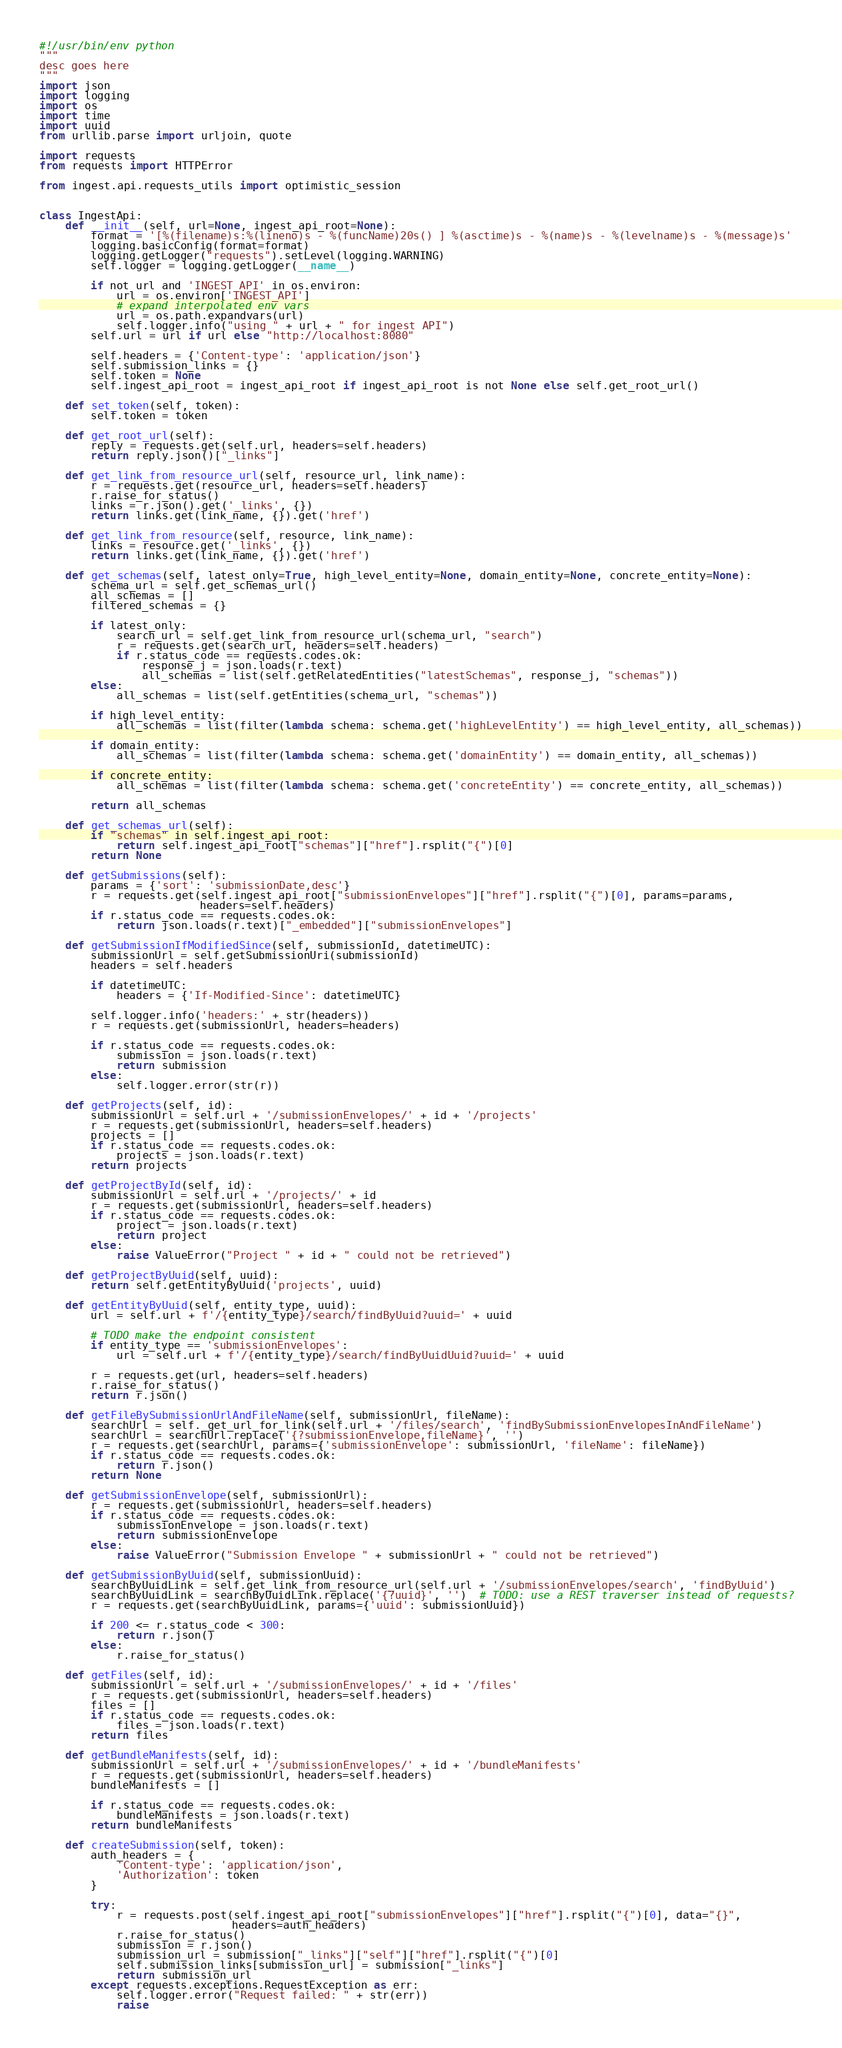Convert code to text. <code><loc_0><loc_0><loc_500><loc_500><_Python_>#!/usr/bin/env python
"""
desc goes here
"""
import json
import logging
import os
import time
import uuid
from urllib.parse import urljoin, quote

import requests
from requests import HTTPError

from ingest.api.requests_utils import optimistic_session


class IngestApi:
    def __init__(self, url=None, ingest_api_root=None):
        format = '[%(filename)s:%(lineno)s - %(funcName)20s() ] %(asctime)s - %(name)s - %(levelname)s - %(message)s'
        logging.basicConfig(format=format)
        logging.getLogger("requests").setLevel(logging.WARNING)
        self.logger = logging.getLogger(__name__)

        if not url and 'INGEST_API' in os.environ:
            url = os.environ['INGEST_API']
            # expand interpolated env vars
            url = os.path.expandvars(url)
            self.logger.info("using " + url + " for ingest API")
        self.url = url if url else "http://localhost:8080"

        self.headers = {'Content-type': 'application/json'}
        self.submission_links = {}
        self.token = None
        self.ingest_api_root = ingest_api_root if ingest_api_root is not None else self.get_root_url()

    def set_token(self, token):
        self.token = token

    def get_root_url(self):
        reply = requests.get(self.url, headers=self.headers)
        return reply.json()["_links"]

    def get_link_from_resource_url(self, resource_url, link_name):
        r = requests.get(resource_url, headers=self.headers)
        r.raise_for_status()
        links = r.json().get('_links', {})
        return links.get(link_name, {}).get('href')

    def get_link_from_resource(self, resource, link_name):
        links = resource.get('_links', {})
        return links.get(link_name, {}).get('href')

    def get_schemas(self, latest_only=True, high_level_entity=None, domain_entity=None, concrete_entity=None):
        schema_url = self.get_schemas_url()
        all_schemas = []
        filtered_schemas = {}

        if latest_only:
            search_url = self.get_link_from_resource_url(schema_url, "search")
            r = requests.get(search_url, headers=self.headers)
            if r.status_code == requests.codes.ok:
                response_j = json.loads(r.text)
                all_schemas = list(self.getRelatedEntities("latestSchemas", response_j, "schemas"))
        else:
            all_schemas = list(self.getEntities(schema_url, "schemas"))

        if high_level_entity:
            all_schemas = list(filter(lambda schema: schema.get('highLevelEntity') == high_level_entity, all_schemas))

        if domain_entity:
            all_schemas = list(filter(lambda schema: schema.get('domainEntity') == domain_entity, all_schemas))

        if concrete_entity:
            all_schemas = list(filter(lambda schema: schema.get('concreteEntity') == concrete_entity, all_schemas))

        return all_schemas

    def get_schemas_url(self):
        if "schemas" in self.ingest_api_root:
            return self.ingest_api_root["schemas"]["href"].rsplit("{")[0]
        return None

    def getSubmissions(self):
        params = {'sort': 'submissionDate,desc'}
        r = requests.get(self.ingest_api_root["submissionEnvelopes"]["href"].rsplit("{")[0], params=params,
                         headers=self.headers)
        if r.status_code == requests.codes.ok:
            return json.loads(r.text)["_embedded"]["submissionEnvelopes"]

    def getSubmissionIfModifiedSince(self, submissionId, datetimeUTC):
        submissionUrl = self.getSubmissionUri(submissionId)
        headers = self.headers

        if datetimeUTC:
            headers = {'If-Modified-Since': datetimeUTC}

        self.logger.info('headers:' + str(headers))
        r = requests.get(submissionUrl, headers=headers)

        if r.status_code == requests.codes.ok:
            submission = json.loads(r.text)
            return submission
        else:
            self.logger.error(str(r))

    def getProjects(self, id):
        submissionUrl = self.url + '/submissionEnvelopes/' + id + '/projects'
        r = requests.get(submissionUrl, headers=self.headers)
        projects = []
        if r.status_code == requests.codes.ok:
            projects = json.loads(r.text)
        return projects

    def getProjectById(self, id):
        submissionUrl = self.url + '/projects/' + id
        r = requests.get(submissionUrl, headers=self.headers)
        if r.status_code == requests.codes.ok:
            project = json.loads(r.text)
            return project
        else:
            raise ValueError("Project " + id + " could not be retrieved")

    def getProjectByUuid(self, uuid):
        return self.getEntityByUuid('projects', uuid)

    def getEntityByUuid(self, entity_type, uuid):
        url = self.url + f'/{entity_type}/search/findByUuid?uuid=' + uuid

        # TODO make the endpoint consistent
        if entity_type == 'submissionEnvelopes':
            url = self.url + f'/{entity_type}/search/findByUuidUuid?uuid=' + uuid

        r = requests.get(url, headers=self.headers)
        r.raise_for_status()
        return r.json()

    def getFileBySubmissionUrlAndFileName(self, submissionUrl, fileName):
        searchUrl = self._get_url_for_link(self.url + '/files/search', 'findBySubmissionEnvelopesInAndFileName')
        searchUrl = searchUrl.replace('{?submissionEnvelope,fileName}', '')
        r = requests.get(searchUrl, params={'submissionEnvelope': submissionUrl, 'fileName': fileName})
        if r.status_code == requests.codes.ok:
            return r.json()
        return None

    def getSubmissionEnvelope(self, submissionUrl):
        r = requests.get(submissionUrl, headers=self.headers)
        if r.status_code == requests.codes.ok:
            submissionEnvelope = json.loads(r.text)
            return submissionEnvelope
        else:
            raise ValueError("Submission Envelope " + submissionUrl + " could not be retrieved")

    def getSubmissionByUuid(self, submissionUuid):
        searchByUuidLink = self.get_link_from_resource_url(self.url + '/submissionEnvelopes/search', 'findByUuid')
        searchByUuidLink = searchByUuidLink.replace('{?uuid}', '')  # TODO: use a REST traverser instead of requests?
        r = requests.get(searchByUuidLink, params={'uuid': submissionUuid})

        if 200 <= r.status_code < 300:
            return r.json()
        else:
            r.raise_for_status()

    def getFiles(self, id):
        submissionUrl = self.url + '/submissionEnvelopes/' + id + '/files'
        r = requests.get(submissionUrl, headers=self.headers)
        files = []
        if r.status_code == requests.codes.ok:
            files = json.loads(r.text)
        return files

    def getBundleManifests(self, id):
        submissionUrl = self.url + '/submissionEnvelopes/' + id + '/bundleManifests'
        r = requests.get(submissionUrl, headers=self.headers)
        bundleManifests = []

        if r.status_code == requests.codes.ok:
            bundleManifests = json.loads(r.text)
        return bundleManifests

    def createSubmission(self, token):
        auth_headers = {
            'Content-type': 'application/json',
            'Authorization': token
        }

        try:
            r = requests.post(self.ingest_api_root["submissionEnvelopes"]["href"].rsplit("{")[0], data="{}",
                              headers=auth_headers)
            r.raise_for_status()
            submission = r.json()
            submission_url = submission["_links"]["self"]["href"].rsplit("{")[0]
            self.submission_links[submission_url] = submission["_links"]
            return submission_url
        except requests.exceptions.RequestException as err:
            self.logger.error("Request failed: " + str(err))
            raise
</code> 